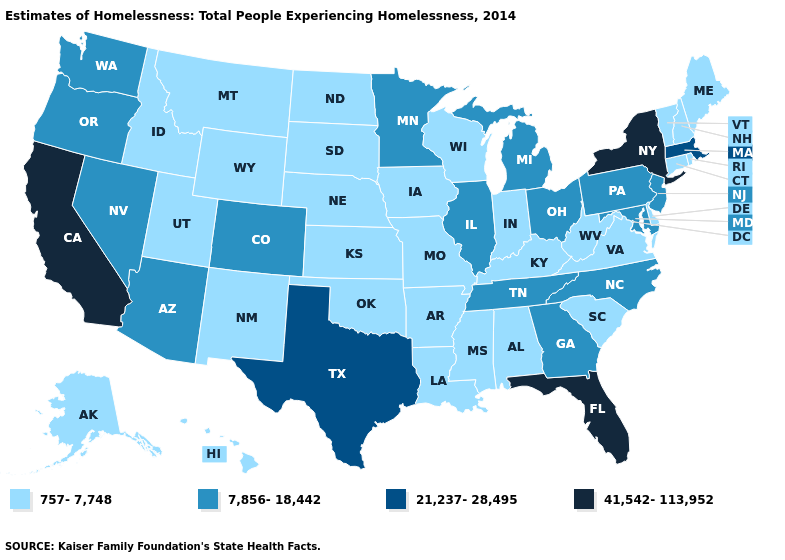Name the states that have a value in the range 7,856-18,442?
Write a very short answer. Arizona, Colorado, Georgia, Illinois, Maryland, Michigan, Minnesota, Nevada, New Jersey, North Carolina, Ohio, Oregon, Pennsylvania, Tennessee, Washington. Among the states that border North Dakota , which have the highest value?
Answer briefly. Minnesota. Name the states that have a value in the range 41,542-113,952?
Give a very brief answer. California, Florida, New York. Name the states that have a value in the range 757-7,748?
Concise answer only. Alabama, Alaska, Arkansas, Connecticut, Delaware, Hawaii, Idaho, Indiana, Iowa, Kansas, Kentucky, Louisiana, Maine, Mississippi, Missouri, Montana, Nebraska, New Hampshire, New Mexico, North Dakota, Oklahoma, Rhode Island, South Carolina, South Dakota, Utah, Vermont, Virginia, West Virginia, Wisconsin, Wyoming. Name the states that have a value in the range 757-7,748?
Short answer required. Alabama, Alaska, Arkansas, Connecticut, Delaware, Hawaii, Idaho, Indiana, Iowa, Kansas, Kentucky, Louisiana, Maine, Mississippi, Missouri, Montana, Nebraska, New Hampshire, New Mexico, North Dakota, Oklahoma, Rhode Island, South Carolina, South Dakota, Utah, Vermont, Virginia, West Virginia, Wisconsin, Wyoming. Does the map have missing data?
Short answer required. No. What is the lowest value in the South?
Give a very brief answer. 757-7,748. Does Nevada have the lowest value in the USA?
Concise answer only. No. Does Florida have the lowest value in the USA?
Be succinct. No. Among the states that border Rhode Island , which have the highest value?
Keep it brief. Massachusetts. Does the first symbol in the legend represent the smallest category?
Answer briefly. Yes. Among the states that border Oregon , does Nevada have the lowest value?
Write a very short answer. No. What is the value of Kansas?
Concise answer only. 757-7,748. Name the states that have a value in the range 21,237-28,495?
Give a very brief answer. Massachusetts, Texas. 